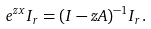<formula> <loc_0><loc_0><loc_500><loc_500>& e ^ { z x } I _ { r } = ( I - z A ) ^ { - 1 } I _ { r } .</formula> 